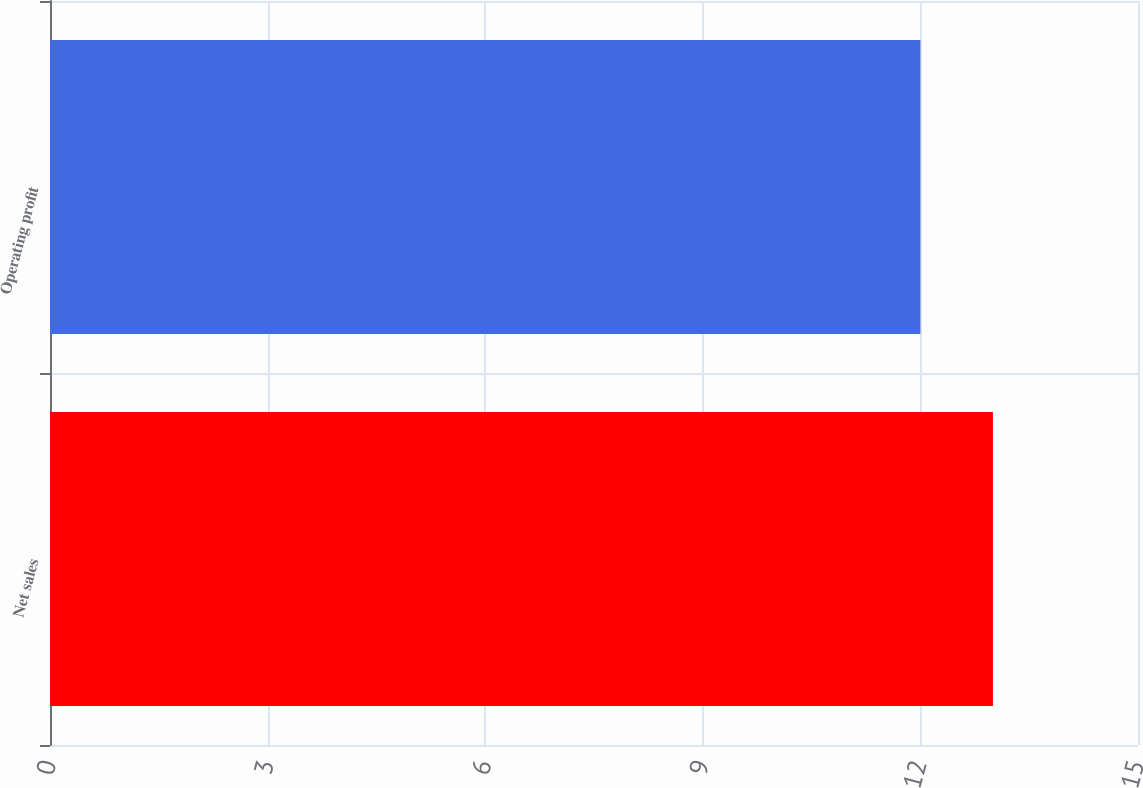<chart> <loc_0><loc_0><loc_500><loc_500><bar_chart><fcel>Net sales<fcel>Operating profit<nl><fcel>13<fcel>12<nl></chart> 